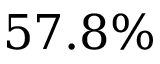<formula> <loc_0><loc_0><loc_500><loc_500>5 7 . 8 \%</formula> 